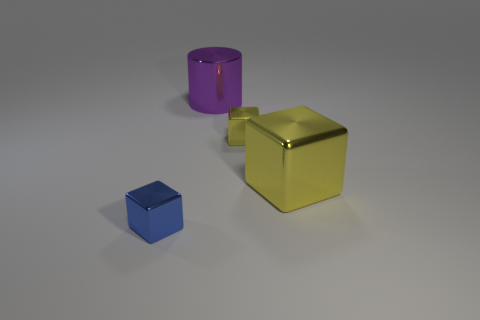Add 2 cylinders. How many objects exist? 6 Subtract all cylinders. How many objects are left? 3 Add 4 tiny brown cylinders. How many tiny brown cylinders exist? 4 Subtract 0 purple spheres. How many objects are left? 4 Subtract all small green shiny cylinders. Subtract all small objects. How many objects are left? 2 Add 3 large yellow metal things. How many large yellow metal things are left? 4 